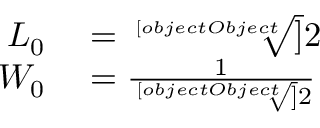<formula> <loc_0><loc_0><loc_500><loc_500>\begin{array} { r l } { L _ { 0 } } & = { \sqrt { [ } [ o b j e c t O b j e c t ] ] { 2 } } } \\ { W _ { 0 } } & = { \frac { 1 } { \sqrt { [ } [ o b j e c t O b j e c t ] ] { 2 } } } } \end{array}</formula> 